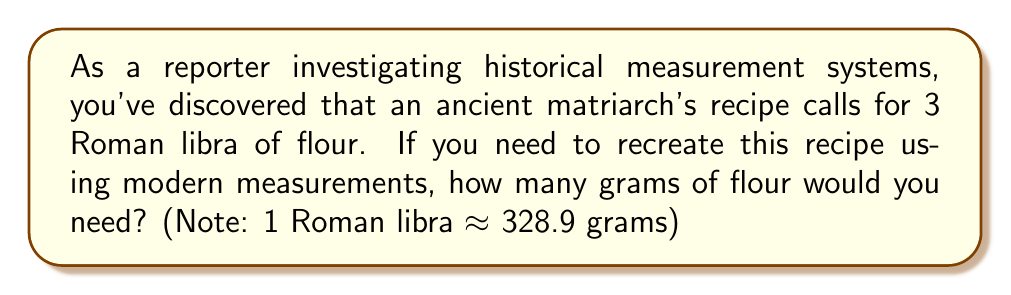Teach me how to tackle this problem. To solve this problem, we need to convert Roman libra to grams. Let's break it down step-by-step:

1. Given information:
   - The recipe requires 3 Roman libra of flour
   - 1 Roman libra ≈ 328.9 grams

2. Set up the conversion:
   We need to multiply the number of Roman libra by the equivalent in grams.

   $$ \text{Total grams} = \text{Number of Roman libra} \times \text{Grams per Roman libra} $$

3. Plug in the values:
   $$ \text{Total grams} = 3 \times 328.9 $$

4. Perform the calculation:
   $$ \text{Total grams} = 986.7 $$

Therefore, to recreate the ancient matriarch's recipe using modern measurements, you would need 986.7 grams of flour.
Answer: 986.7 grams 